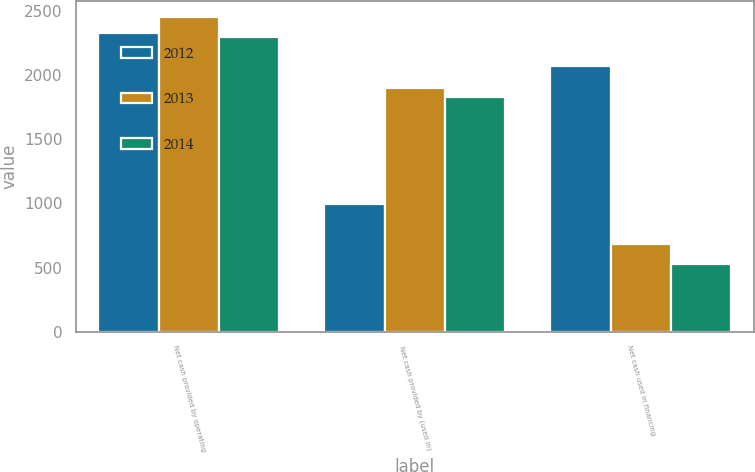Convert chart. <chart><loc_0><loc_0><loc_500><loc_500><stacked_bar_chart><ecel><fcel>Net cash provided by operating<fcel>Net cash provided by (used in)<fcel>Net cash used in financing<nl><fcel>2012<fcel>2331<fcel>995<fcel>2072<nl><fcel>2013<fcel>2455<fcel>1900<fcel>687<nl><fcel>2014<fcel>2295<fcel>1830<fcel>530<nl></chart> 